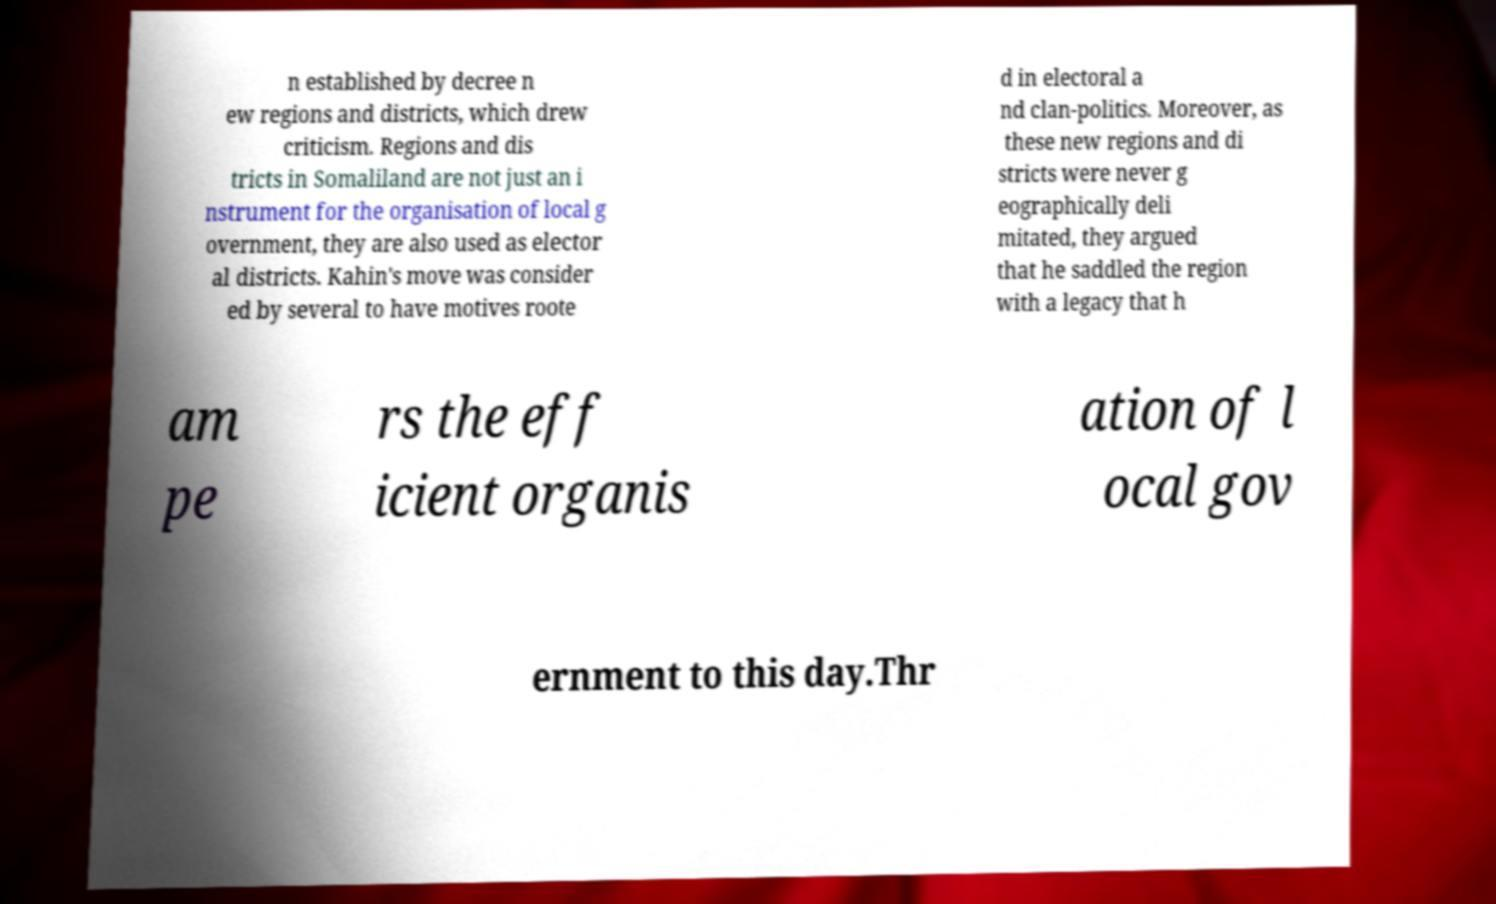What messages or text are displayed in this image? I need them in a readable, typed format. n established by decree n ew regions and districts, which drew criticism. Regions and dis tricts in Somaliland are not just an i nstrument for the organisation of local g overnment, they are also used as elector al districts. Kahin's move was consider ed by several to have motives roote d in electoral a nd clan-politics. Moreover, as these new regions and di stricts were never g eographically deli mitated, they argued that he saddled the region with a legacy that h am pe rs the eff icient organis ation of l ocal gov ernment to this day.Thr 